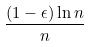<formula> <loc_0><loc_0><loc_500><loc_500>\frac { ( 1 - \epsilon ) \ln n } { n }</formula> 